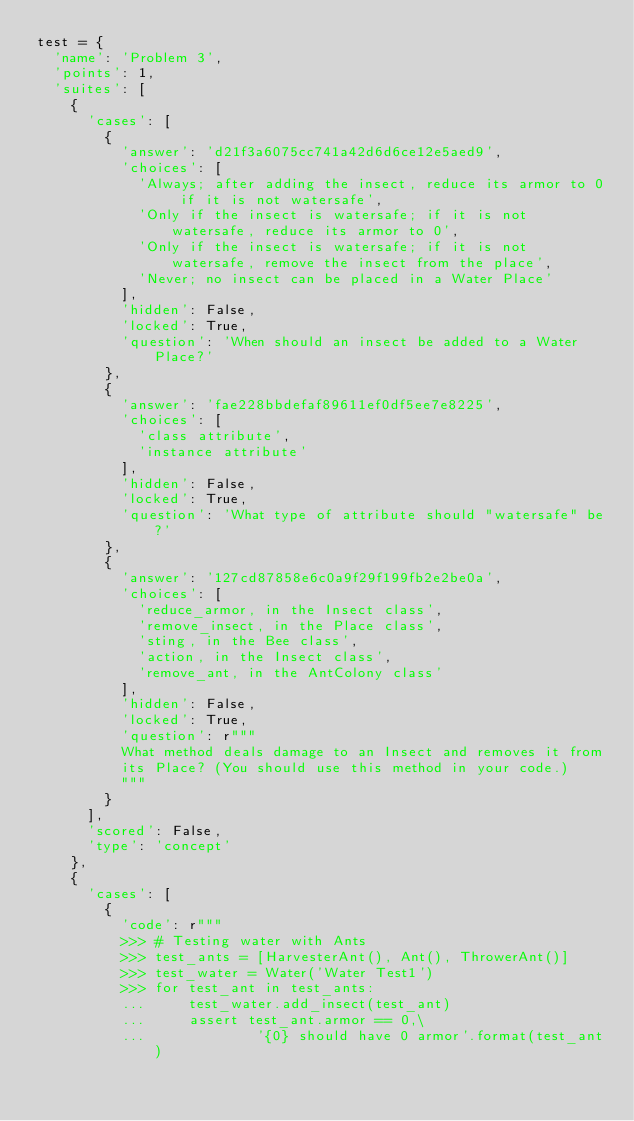Convert code to text. <code><loc_0><loc_0><loc_500><loc_500><_Python_>test = {
  'name': 'Problem 3',
  'points': 1,
  'suites': [
    {
      'cases': [
        {
          'answer': 'd21f3a6075cc741a42d6d6ce12e5aed9',
          'choices': [
            'Always; after adding the insect, reduce its armor to 0 if it is not watersafe',
            'Only if the insect is watersafe; if it is not watersafe, reduce its armor to 0',
            'Only if the insect is watersafe; if it is not watersafe, remove the insect from the place',
            'Never; no insect can be placed in a Water Place'
          ],
          'hidden': False,
          'locked': True,
          'question': 'When should an insect be added to a Water Place?'
        },
        {
          'answer': 'fae228bbdefaf89611ef0df5ee7e8225',
          'choices': [
            'class attribute',
            'instance attribute'
          ],
          'hidden': False,
          'locked': True,
          'question': 'What type of attribute should "watersafe" be?'
        },
        {
          'answer': '127cd87858e6c0a9f29f199fb2e2be0a',
          'choices': [
            'reduce_armor, in the Insect class',
            'remove_insect, in the Place class',
            'sting, in the Bee class',
            'action, in the Insect class',
            'remove_ant, in the AntColony class'
          ],
          'hidden': False,
          'locked': True,
          'question': r"""
          What method deals damage to an Insect and removes it from
          its Place? (You should use this method in your code.)
          """
        }
      ],
      'scored': False,
      'type': 'concept'
    },
    {
      'cases': [
        {
          'code': r"""
          >>> # Testing water with Ants
          >>> test_ants = [HarvesterAnt(), Ant(), ThrowerAnt()]
          >>> test_water = Water('Water Test1')
          >>> for test_ant in test_ants:
          ...     test_water.add_insect(test_ant)
          ...     assert test_ant.armor == 0,\
          ...             '{0} should have 0 armor'.format(test_ant)</code> 